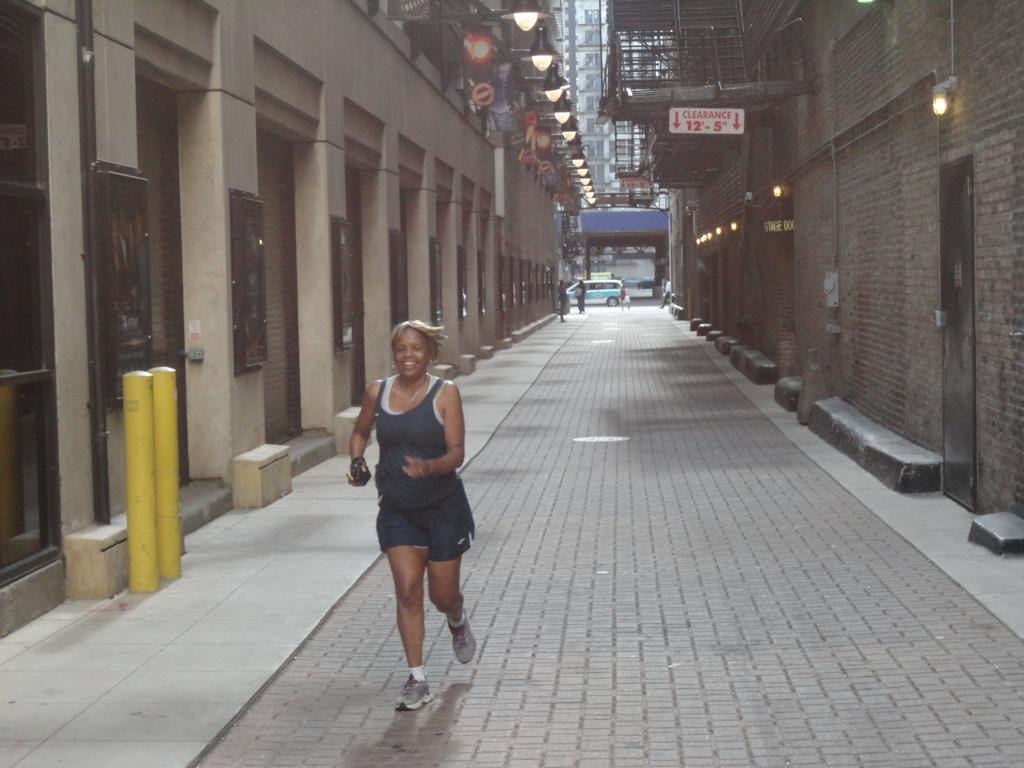Can you describe this image briefly? In this image a woman wearing a shoes is running on the road. There are two poles on the pavement. On both side of image there are few buildings having few lights attached to the walls of building. There is a car on the road. Few persons are walking on pavement. Behind there is a building. 